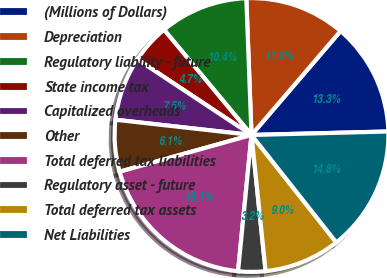Convert chart. <chart><loc_0><loc_0><loc_500><loc_500><pie_chart><fcel>(Millions of Dollars)<fcel>Depreciation<fcel>Regulatory liability - future<fcel>State income tax<fcel>Capitalized overheads<fcel>Other<fcel>Total deferred tax liabilities<fcel>Regulatory asset - future<fcel>Total deferred tax assets<fcel>Net Liabilities<nl><fcel>13.32%<fcel>11.88%<fcel>10.43%<fcel>4.65%<fcel>7.54%<fcel>6.1%<fcel>19.11%<fcel>3.21%<fcel>8.99%<fcel>14.77%<nl></chart> 